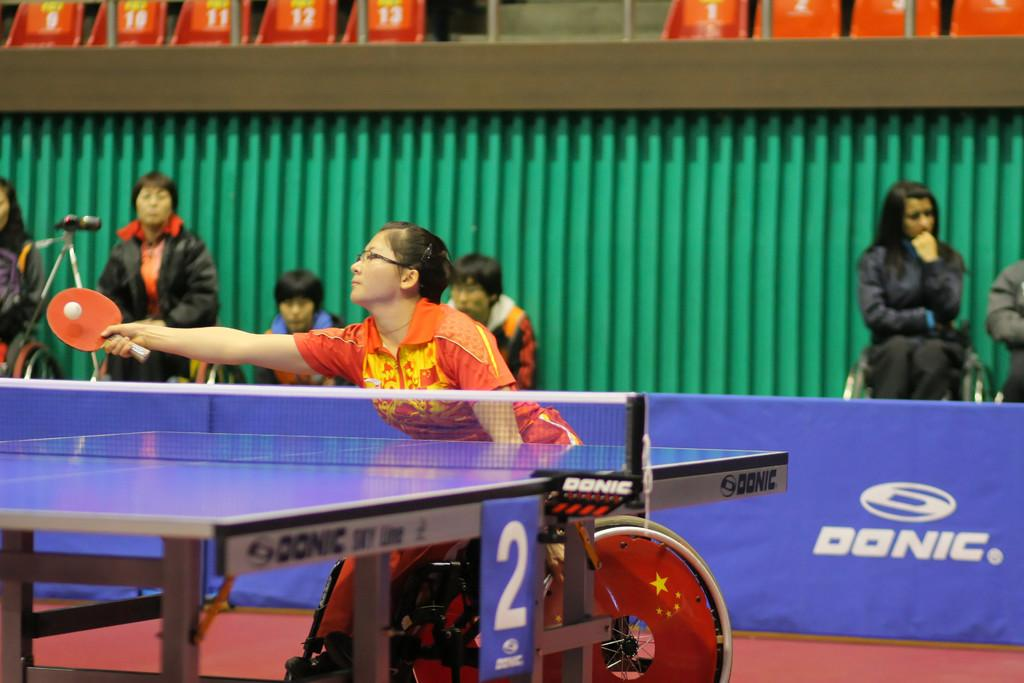What are the people in the image doing? The people are sitting and standing behind a hoarding. Can you describe the seating arrangement in the image? There are empty chairs at the top of the image. What activity is the woman in the wheelchair engaged in? The woman is playing table tennis while seated in a wheelchair. What type of mass is being conducted in the image? There is no mass being conducted in the image. Can you describe the building in the background of the image? There is no building visible in the image. What apparatus is the woman using to play table tennis? The woman is playing table tennis using a table tennis paddle, which is not referred to as an apparatus in the image. 